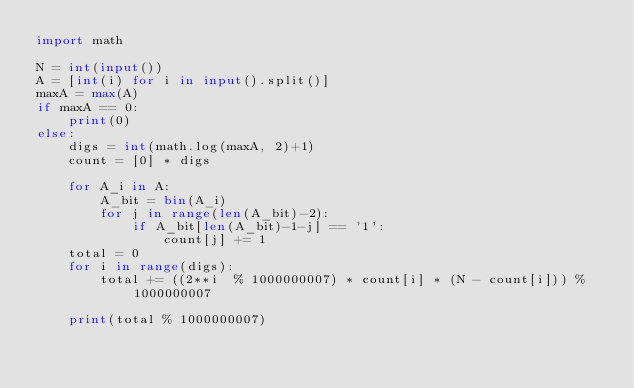Convert code to text. <code><loc_0><loc_0><loc_500><loc_500><_Python_>import math

N = int(input())
A = [int(i) for i in input().split()]
maxA = max(A)
if maxA == 0:
    print(0)
else:   
    digs = int(math.log(maxA, 2)+1)
    count = [0] * digs
    
    for A_i in A:
        A_bit = bin(A_i)
        for j in range(len(A_bit)-2):
            if A_bit[len(A_bit)-1-j] == '1':
                count[j] += 1
    total = 0
    for i in range(digs):
        total += ((2**i  % 1000000007) * count[i] * (N - count[i])) % 1000000007
        
    print(total % 1000000007)</code> 